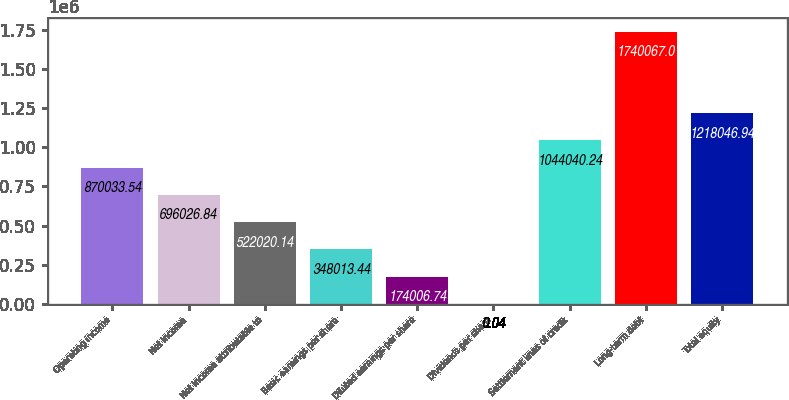Convert chart to OTSL. <chart><loc_0><loc_0><loc_500><loc_500><bar_chart><fcel>Operating income<fcel>Net income<fcel>Net income attributable to<fcel>Basic earnings per share<fcel>Diluted earnings per share<fcel>Dividends per share<fcel>Settlement lines of credit<fcel>Long-term debt<fcel>Total equity<nl><fcel>870034<fcel>696027<fcel>522020<fcel>348013<fcel>174007<fcel>0.04<fcel>1.04404e+06<fcel>1.74007e+06<fcel>1.21805e+06<nl></chart> 